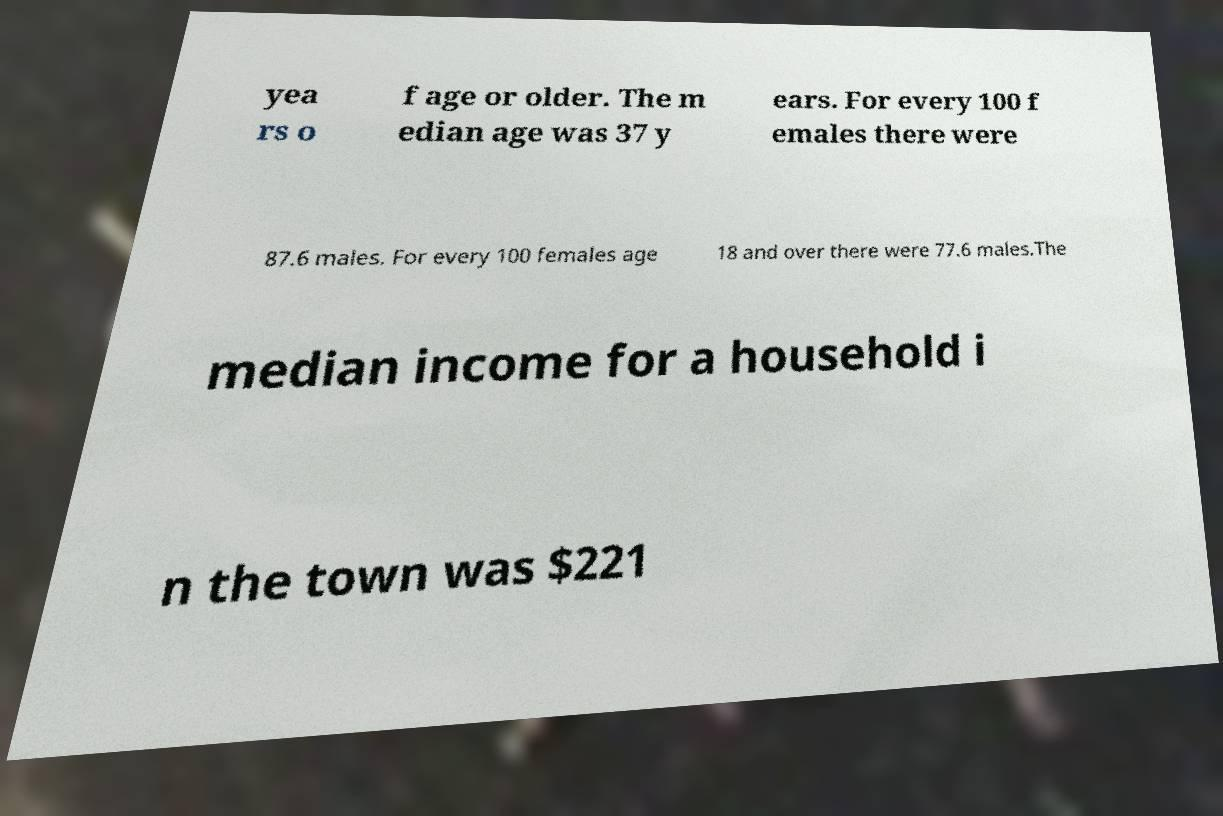Can you read and provide the text displayed in the image?This photo seems to have some interesting text. Can you extract and type it out for me? yea rs o f age or older. The m edian age was 37 y ears. For every 100 f emales there were 87.6 males. For every 100 females age 18 and over there were 77.6 males.The median income for a household i n the town was $221 